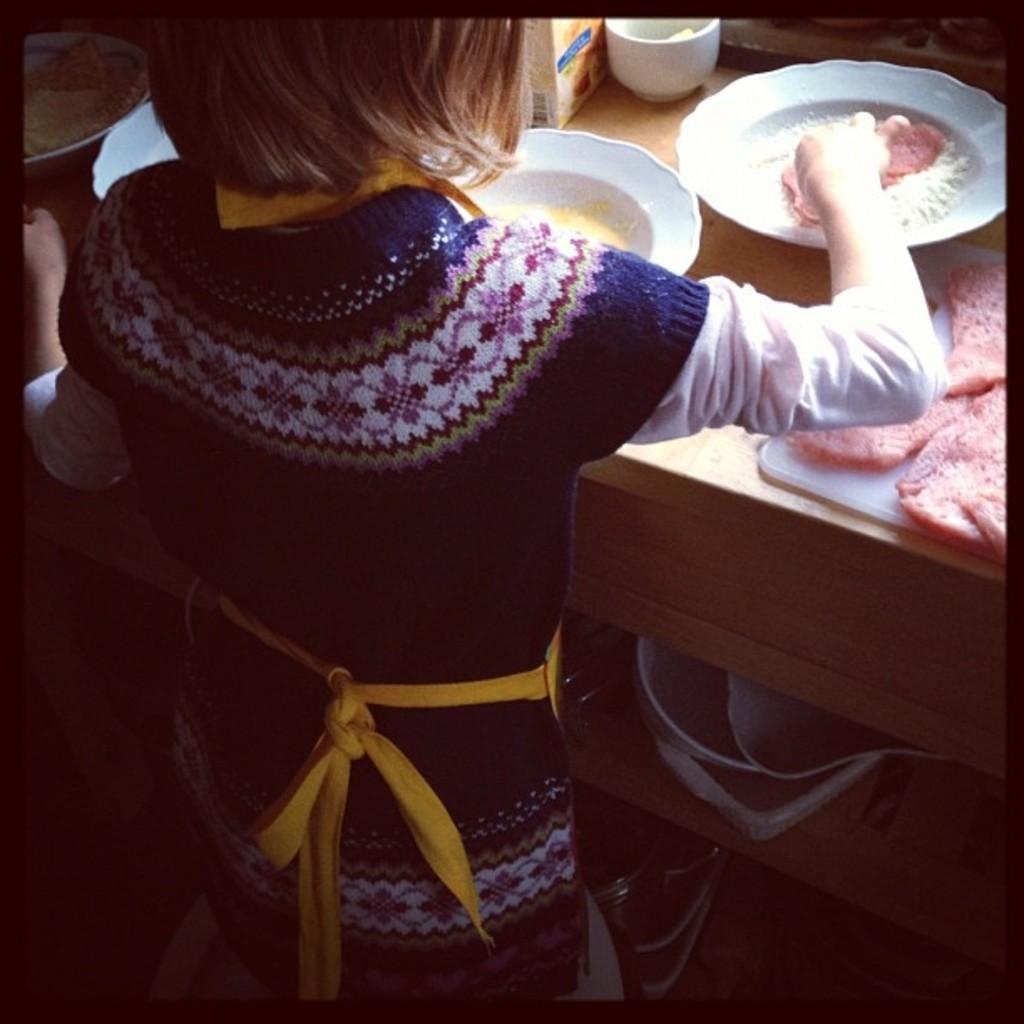What is the main subject in the image? There is a person standing in the image. What is on the table in the image? There are food slices, plates, and a cup on the table. What type of vest is the person wearing in the image? There is no vest visible in the image; the person is not wearing one. Can you see a ball on the table in the image? There is no ball present on the table in the image. 